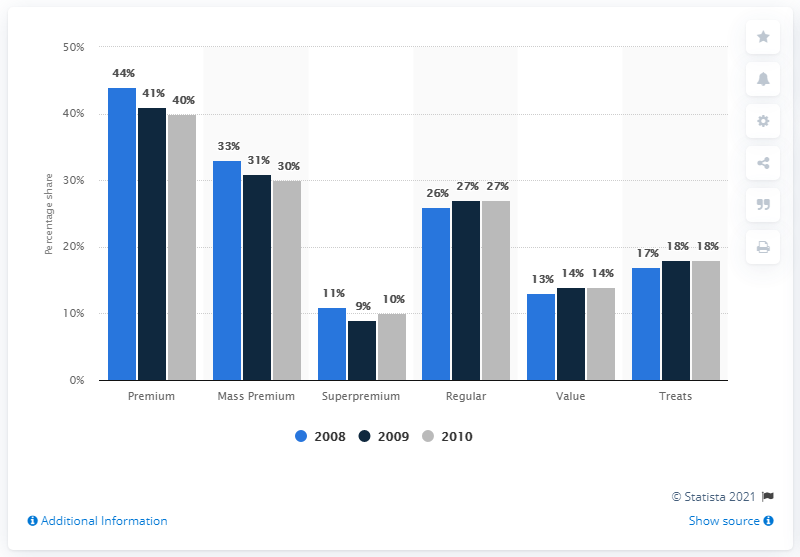Is there a significant change in the market share of superpremium category between the years shown? From the image, the 'Superpremium' category shows a marginal decline from 11% in 2008 to 9% in 2009, followed by a slight increase to 10% in 2010. This suggests a relatively small fluctuation in the market share for superpremium dog and cat food across the years presented. 